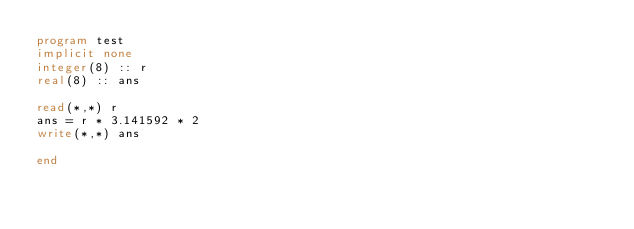Convert code to text. <code><loc_0><loc_0><loc_500><loc_500><_FORTRAN_>program test
implicit none
integer(8) :: r
real(8) :: ans

read(*,*) r
ans = r * 3.141592 * 2
write(*,*) ans

end</code> 